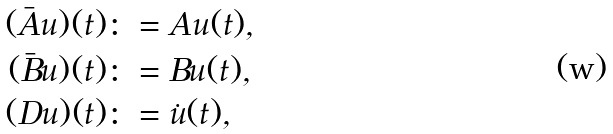Convert formula to latex. <formula><loc_0><loc_0><loc_500><loc_500>( \bar { A } u ) ( t ) & \colon = A u ( t ) , \\ ( \bar { B } u ) ( t ) & \colon = B u ( t ) , \\ ( D u ) ( t ) & \colon = \dot { u } ( t ) ,</formula> 